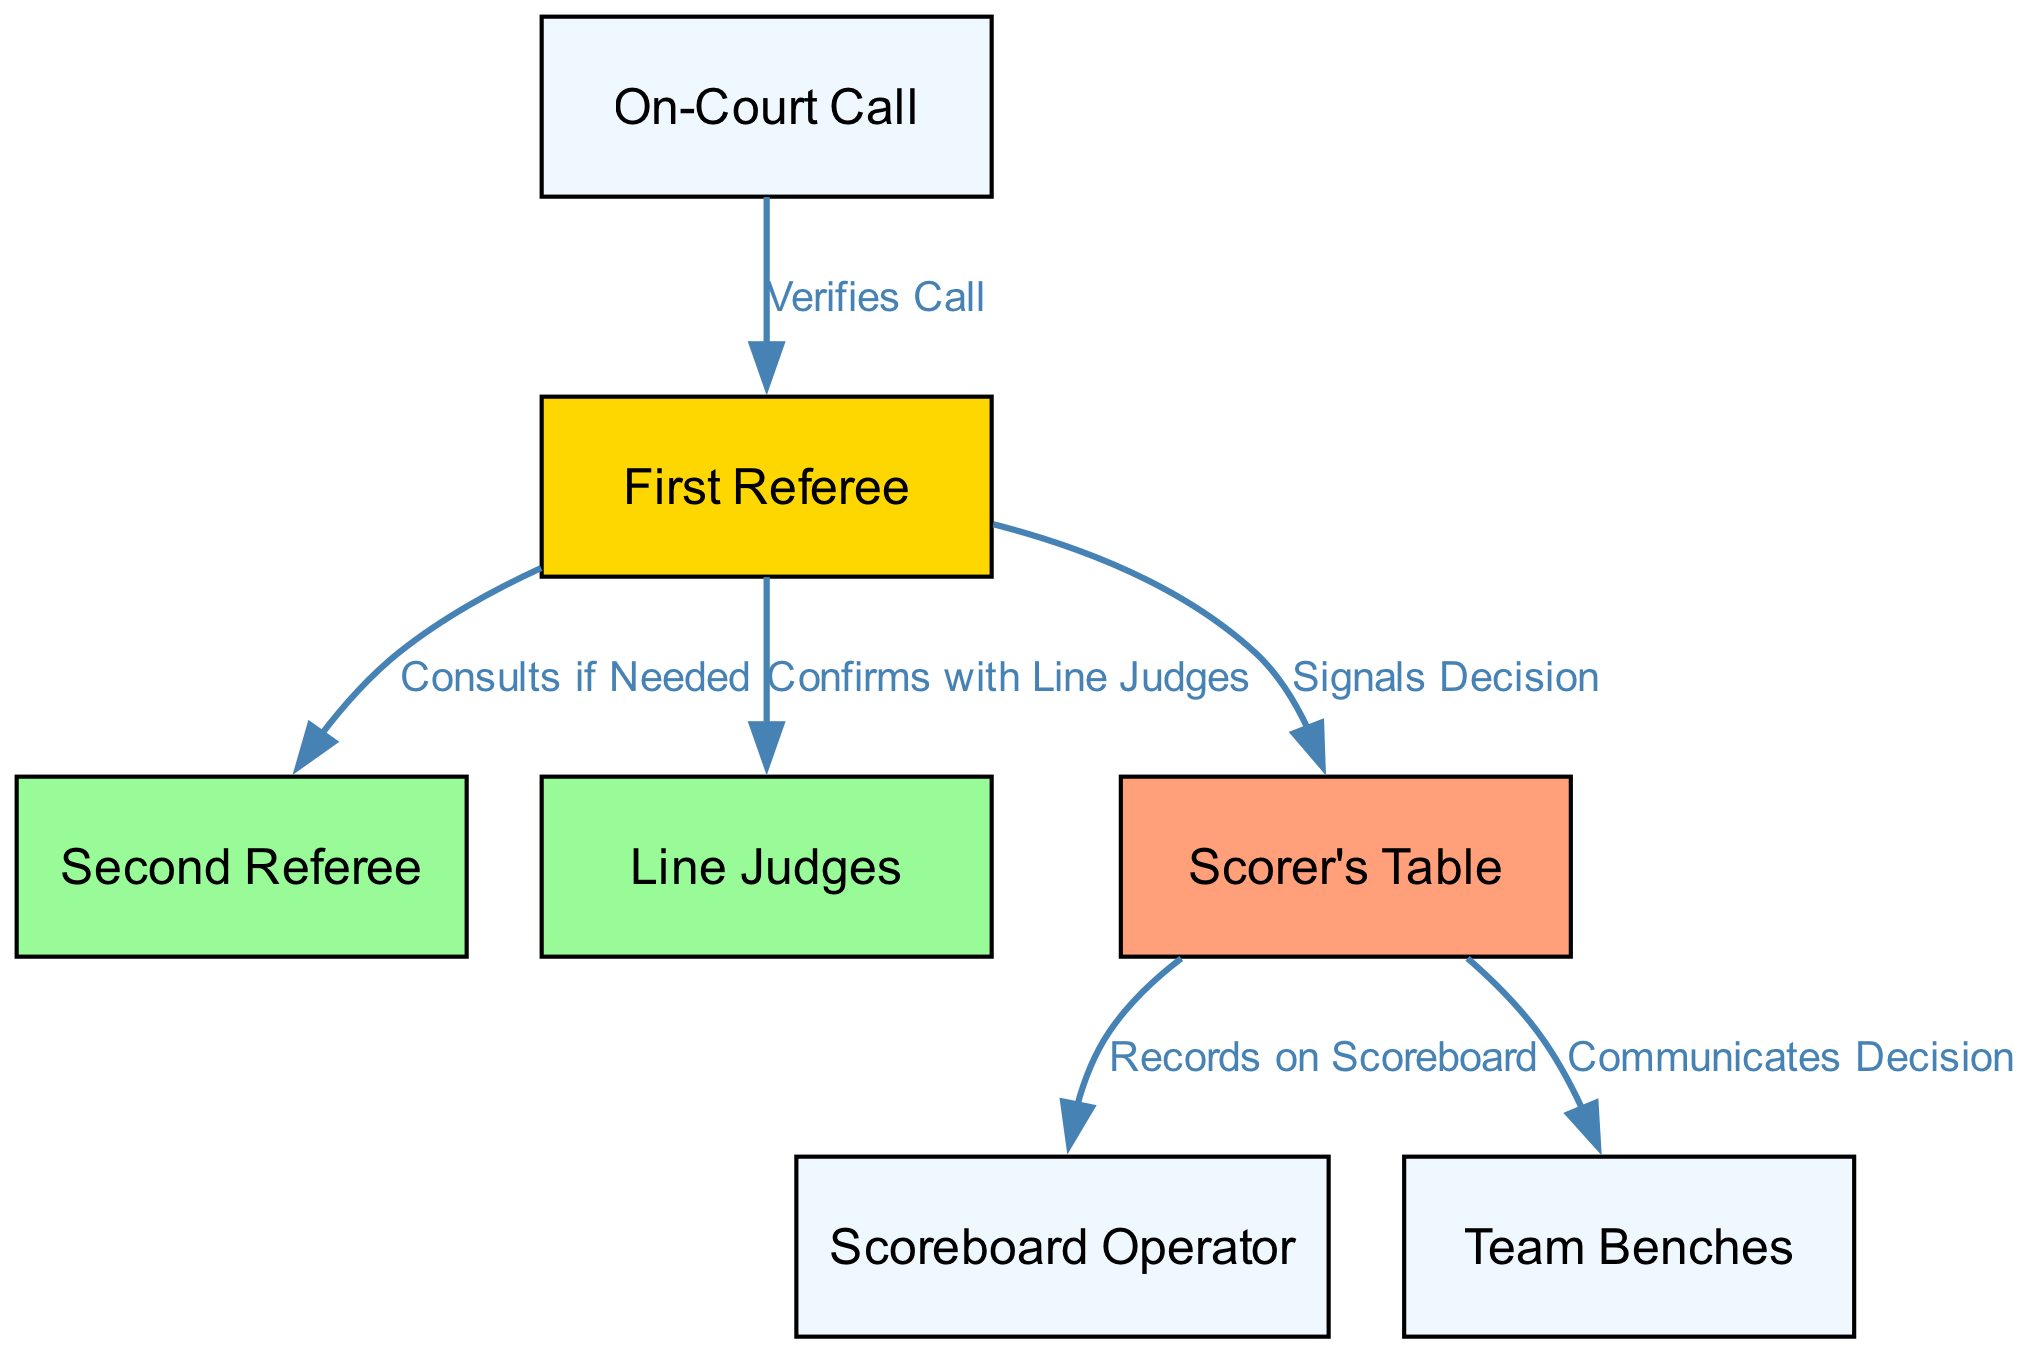What is the first step in the refereeing process? The diagram starts with the "On-Court Call," which is the initial action taken in the refereeing process
Answer: On-Court Call How many referees are involved in the decision-making process? The diagram shows two referees: the First Referee and the Second Referee
Answer: Two Which node confirms with the Line Judges? The First Referee is responsible for confirming the call with the Line Judges
Answer: First Referee What does the Scorer's Table do after receiving a decision from the First Referee? The Scorer's Table signals the decision to the Scoreboard Operator and communicates it to the Team Benches
Answer: Signals Decision In what scenario does the First Referee consult the Second Referee? The First Referee consults the Second Referee if needed, indicating it is a step that occurs when the First Referee is unsure
Answer: Consults if Needed How does the communication flow from the Scorer's Table to the Team Benches? From the Scorer's Table, the decision is communicated directly to the Team Benches, indicating a line of communication established for both teams
Answer: Communicates Decision What action occurs after the Scorer's Table records the decision? The Scoreboard Operator updates the scoreboard to reflect the decision made during the game
Answer: Records on Scoreboard How many edges are shown in the diagram? The diagram contains six edges that represent the flow of actions and communications among the nodes
Answer: Six What color represents the First Referee in the diagram? The First Referee is represented by a gold color, indicating its importance in the decision-making process
Answer: Gold 